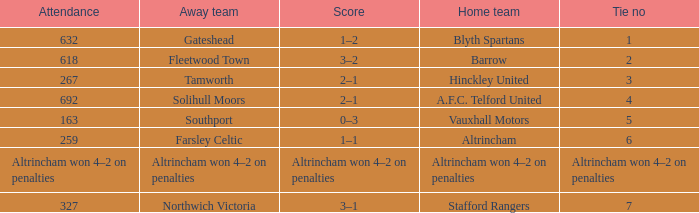What was the number of attendees for the away team solihull moors? 692.0. 